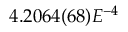Convert formula to latex. <formula><loc_0><loc_0><loc_500><loc_500>4 . 2 0 6 4 ( 6 8 ) E ^ { - 4 }</formula> 